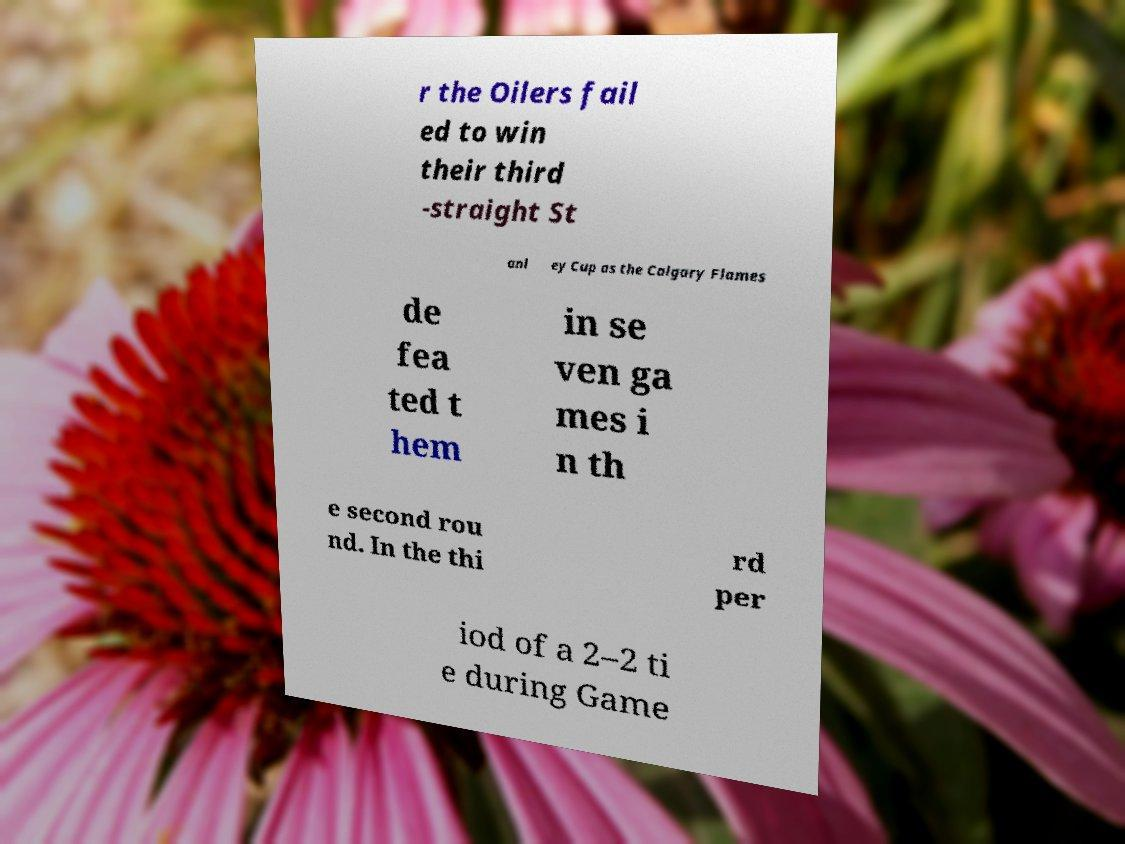Can you accurately transcribe the text from the provided image for me? r the Oilers fail ed to win their third -straight St anl ey Cup as the Calgary Flames de fea ted t hem in se ven ga mes i n th e second rou nd. In the thi rd per iod of a 2–2 ti e during Game 